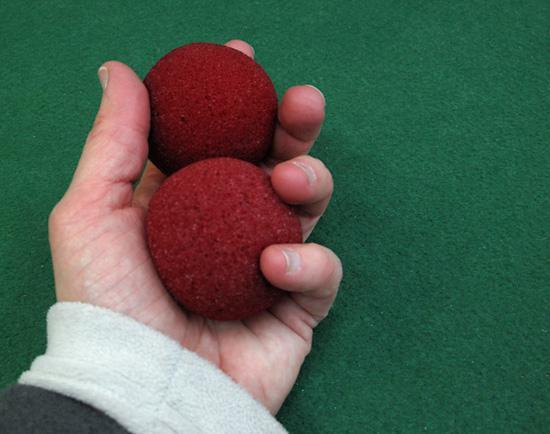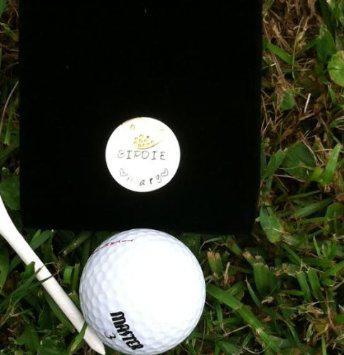The first image is the image on the left, the second image is the image on the right. Analyze the images presented: Is the assertion "Atleast one image of a person holding 2 balls behind their back" valid? Answer yes or no. No. The first image is the image on the left, the second image is the image on the right. Examine the images to the left and right. Is the description "One of the images contains a golf tee touching a golf ball on the ground." accurate? Answer yes or no. Yes. 